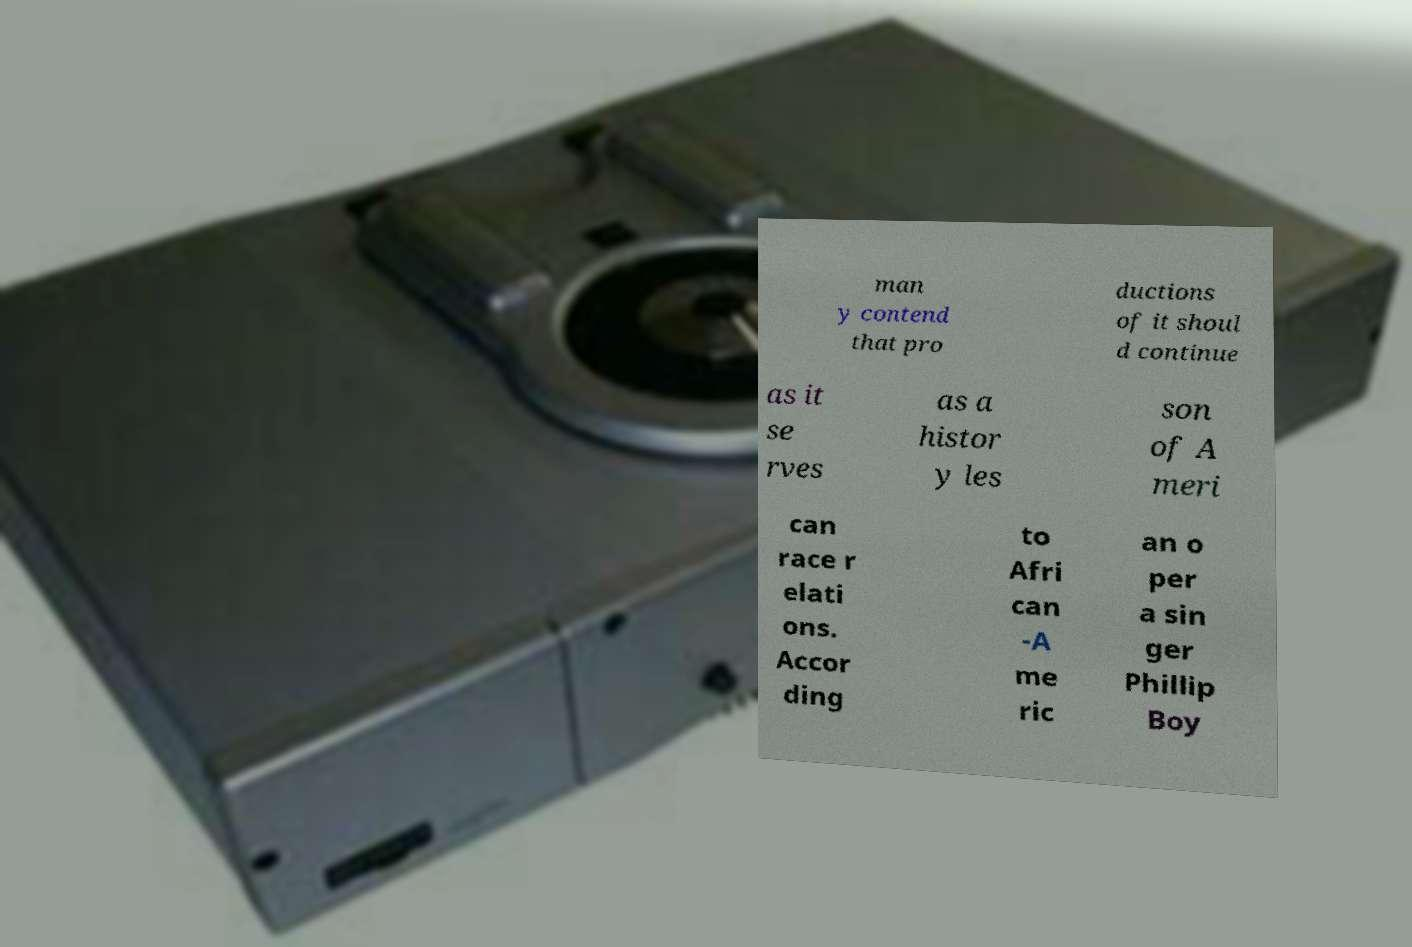What messages or text are displayed in this image? I need them in a readable, typed format. man y contend that pro ductions of it shoul d continue as it se rves as a histor y les son of A meri can race r elati ons. Accor ding to Afri can -A me ric an o per a sin ger Phillip Boy 